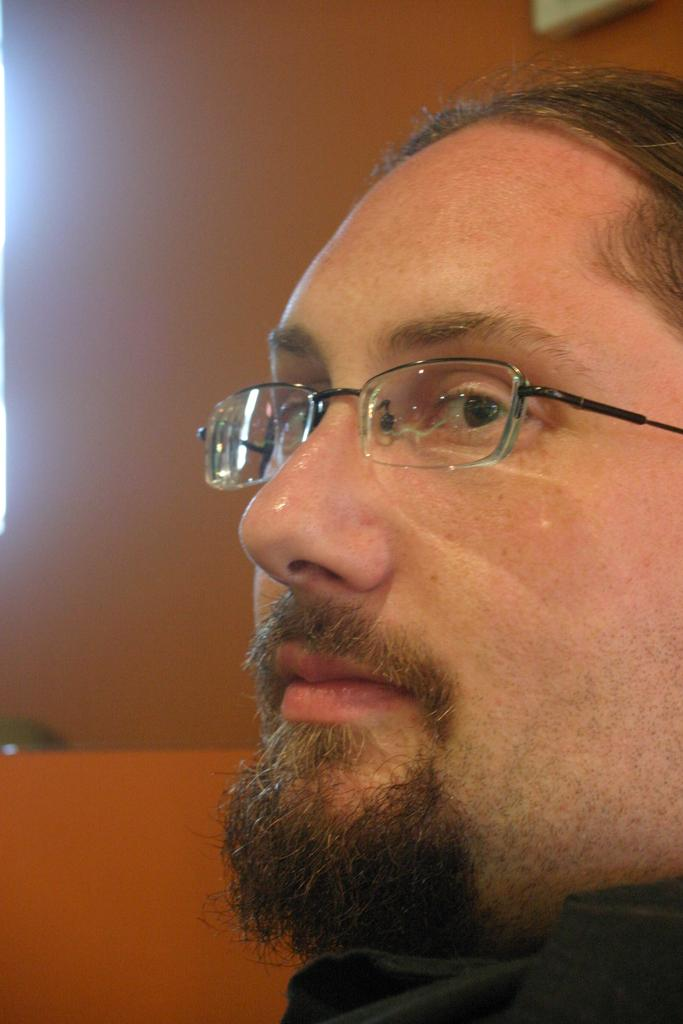Who or what is the main subject of the image? There is a person in the image. What can be observed about the person's appearance? The person is wearing spectacles. What can be seen in the background of the image? There is a photo frame on the wall in the background of the image. What type of plant is growing in the person's hair in the image? There is no plant visible in the person's hair in the image. 